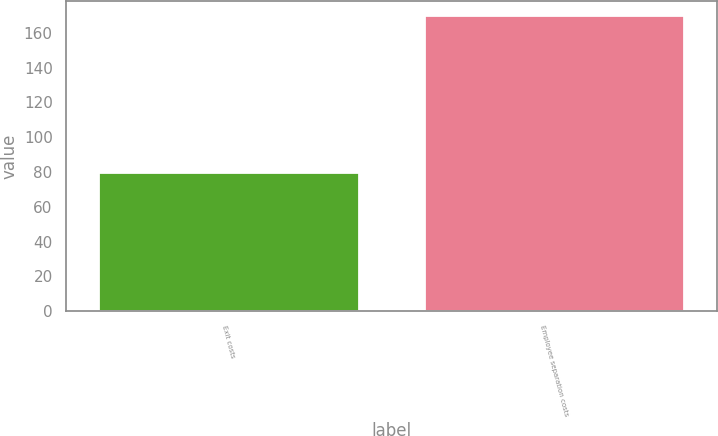Convert chart to OTSL. <chart><loc_0><loc_0><loc_500><loc_500><bar_chart><fcel>Exit costs<fcel>Employee separation costs<nl><fcel>80<fcel>170<nl></chart> 